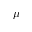<formula> <loc_0><loc_0><loc_500><loc_500>\mu</formula> 